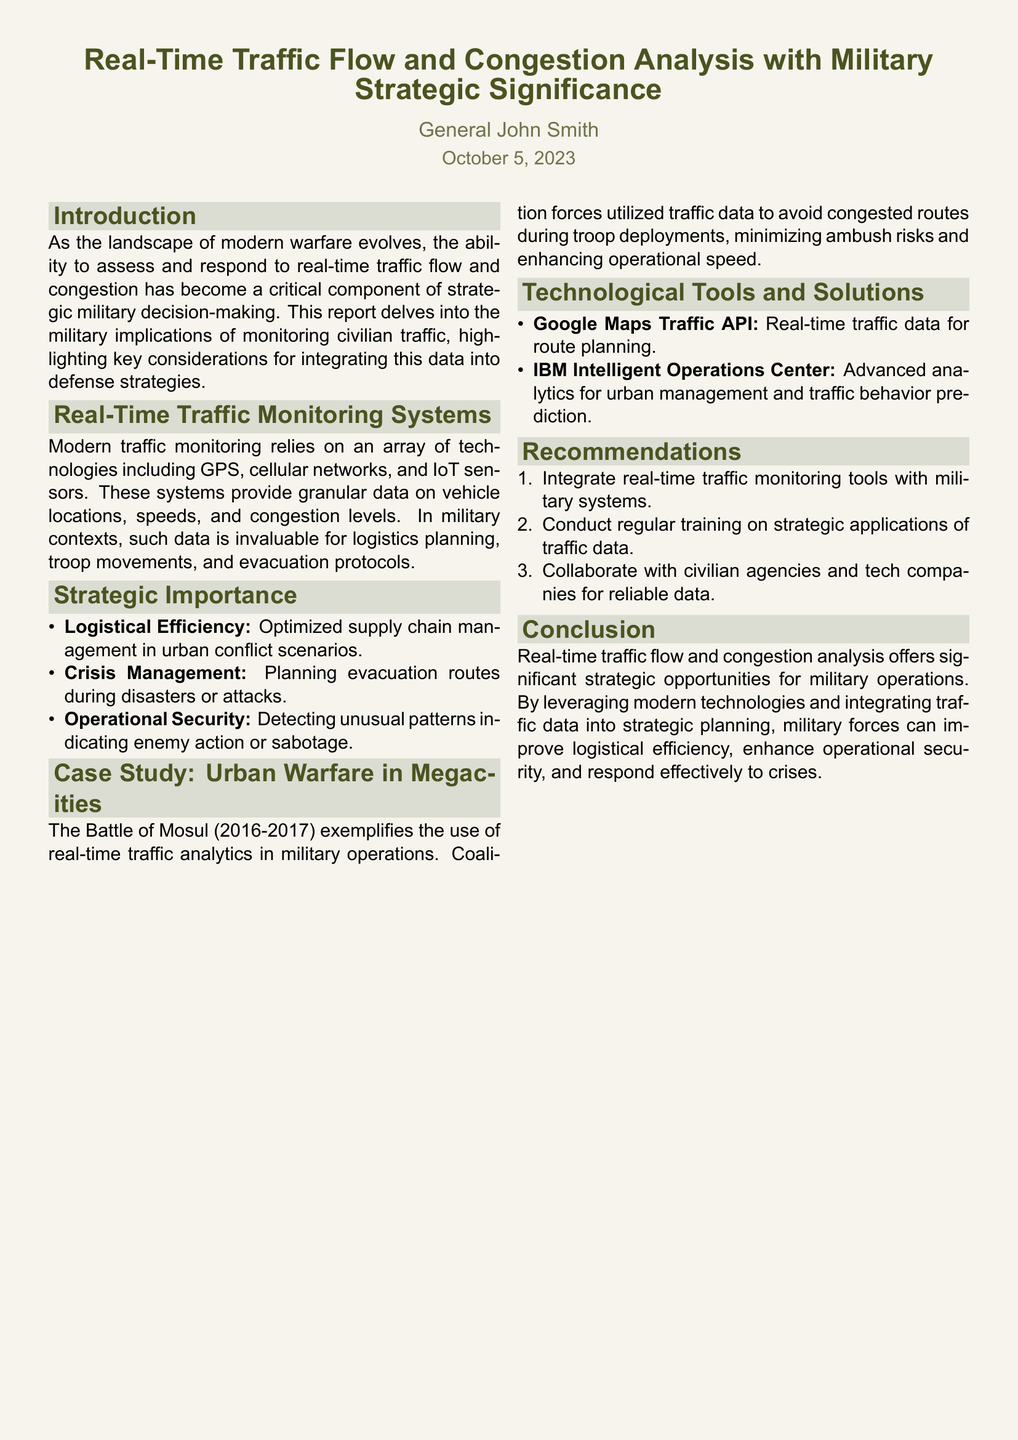what is the title of the report? The title is stated at the beginning of the document, summarizing the content effectively.
Answer: Real-Time Traffic Flow and Congestion Analysis with Military Strategic Significance who is the author of the report? The document lists the author at the top, providing their name as the responsible party for the content.
Answer: General John Smith what date was the report published? The publication date is prominently displayed below the author's name, indicating when the report was finalized.
Answer: October 5, 2023 what technological tool is mentioned for real-time traffic data? The report lists the specific tool in the section on technological tools and solutions as an example of what can be used.
Answer: Google Maps Traffic API what is one strategic importance of real-time traffic monitoring? The document provides a bullet point outlining key strategic benefits of implementing traffic monitoring in military contexts.
Answer: Logistical Efficiency which urban conflict is highlighted in the case study? The case study section specifies the historical event that illustrates traffic analysis usage in military operations.
Answer: Battle of Mosul how many recommendations are made in the report? The 'Recommendations' section contains a numbered list indicating the total number of suggestions provided.
Answer: Three what is one recommended action for military systems? The recommendations section outlines specific actions that are encouraged for better integration with military strategies.
Answer: Integrate real-time traffic monitoring tools with military systems what type of technologies are used for traffic monitoring? The report describes these technologies in a detailed list that includes categories of tools and their purposes.
Answer: GPS, cellular networks, and IoT sensors 